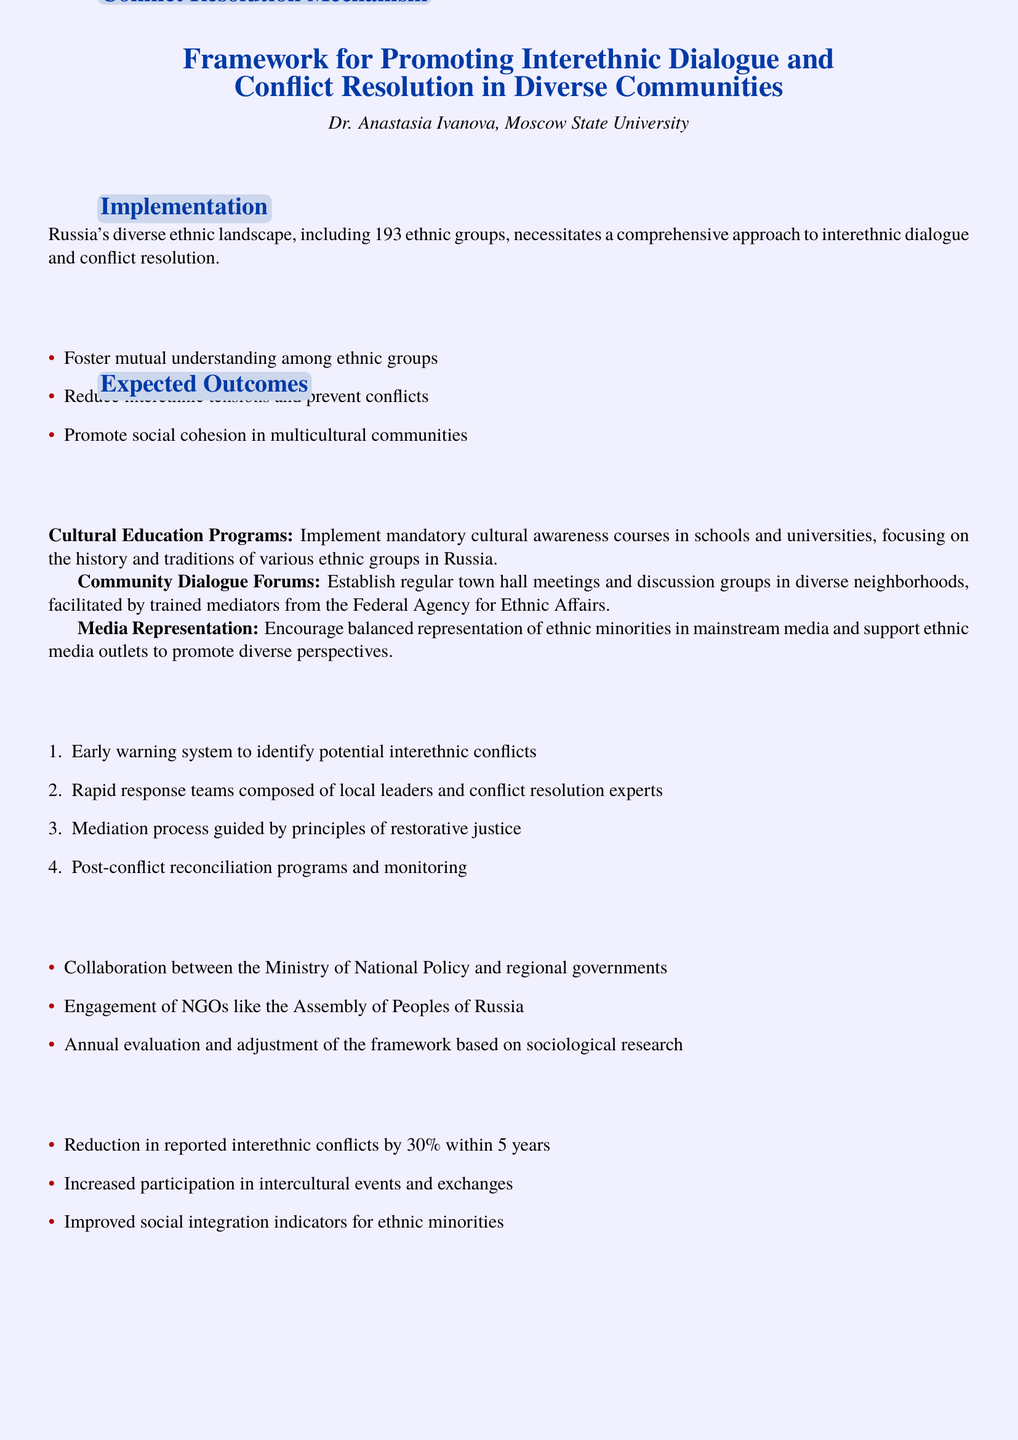What is the title of the document? The title of the document is prominently displayed at the beginning, highlighting its focus on interethnic dialogue and conflict resolution.
Answer: Framework for Promoting Interethnic Dialogue and Conflict Resolution in Diverse Communities Who is the author of the document? The document notes the author’s name and affiliation, providing context for the analysis and recommendations presented.
Answer: Dr. Anastasia Ivanova How many ethnic groups are mentioned in the background? The document specifies the number of ethnic groups in Russia in the background section, indicating the diversity being addressed.
Answer: 193 What is the first objective outlined in the document? The objectives are listed in bullet points, detailing the aims of the framework. The first one emphasizes mutual understanding.
Answer: Foster mutual understanding among ethnic groups What is the expected reduction in interethnic conflicts within 5 years? The expected outcomes section quantifies the goal for conflict reduction, providing a measurable target for success.
Answer: 30% What type of educational programs are proposed? The key strategies outline various approaches to promoting understanding among ethnic groups, one of which is educational in nature.
Answer: Cultural Education Programs Who is responsible for establishing the community dialogue forums? The document indicates who will facilitate the dialogue forums, pointing to the involvement of a specific governmental agency.
Answer: Federal Agency for Ethnic Affairs What principle guides the mediation process in the conflict resolution mechanism? The conflict resolution section mentions a guiding principle, which is key to the mediation efforts outlined.
Answer: Restorative justice 